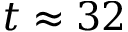Convert formula to latex. <formula><loc_0><loc_0><loc_500><loc_500>t \approx 3 2</formula> 